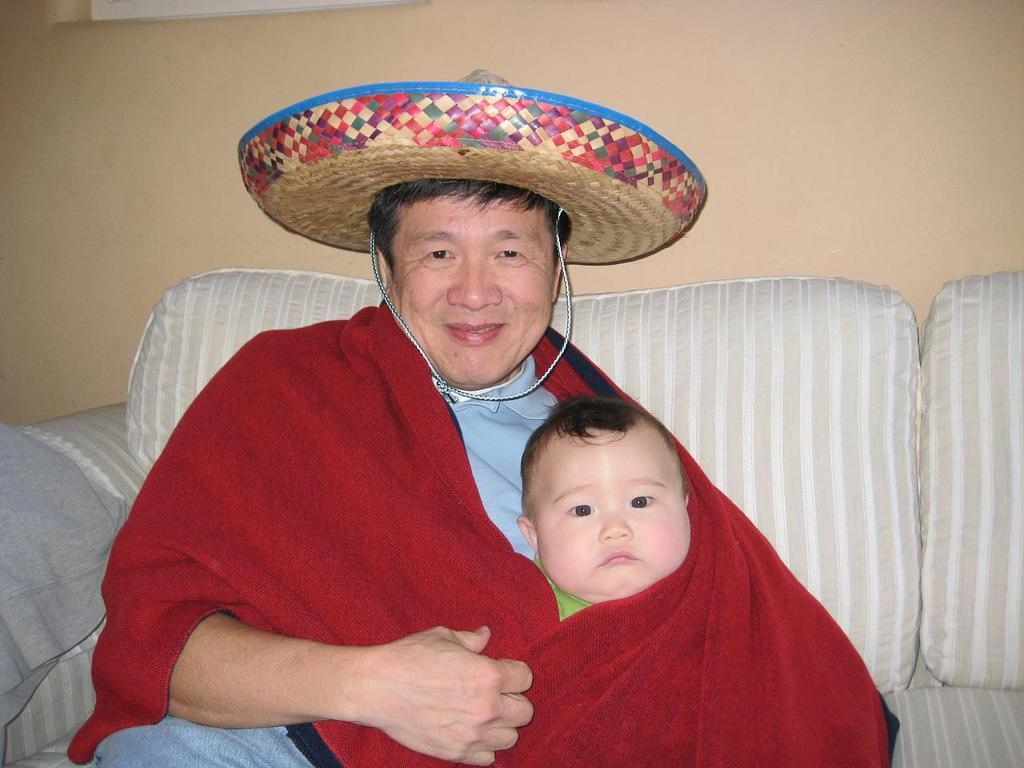How many people are sitting on the sofa in the image? There are two people sitting on the sofa in the image. What is located behind the sofa? There is a wall behind the sofa. What type of property is visible in the image? There is no specific property mentioned or visible in the image; it only shows two people sitting on a sofa with a wall behind it. Are there any lizards crawling on the wall in the image? There are no lizards visible in the image. 